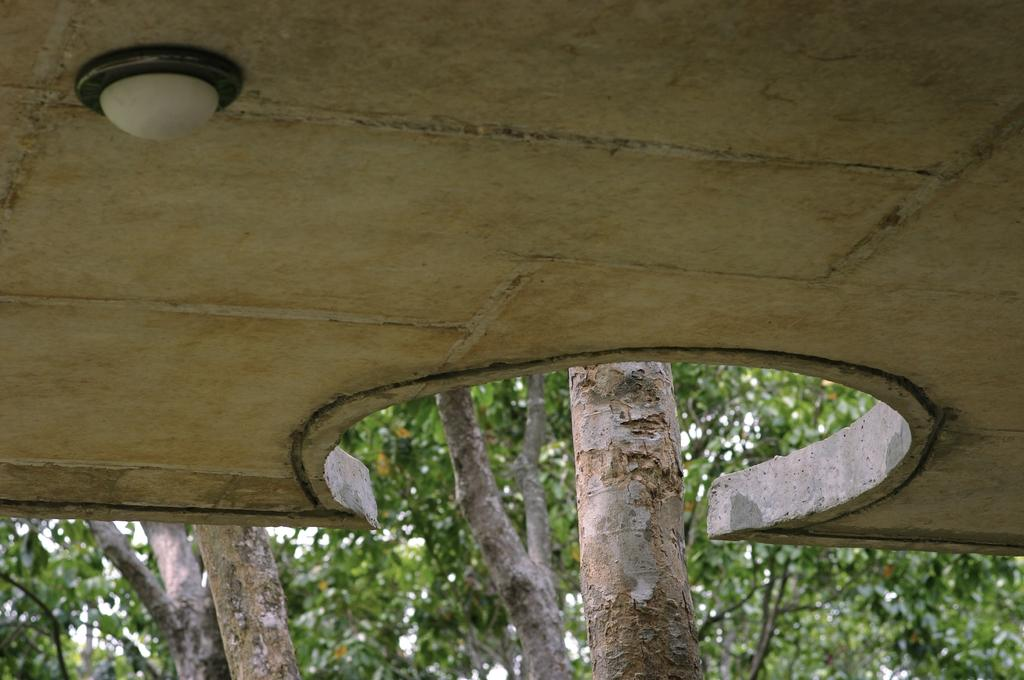What is located at the top of the image? There is a light at the top of the image. What can be seen in the background of the image? There are trees in the background of the image. How does the clock blow in the quicksand in the image? There is no clock or quicksand present in the image. 